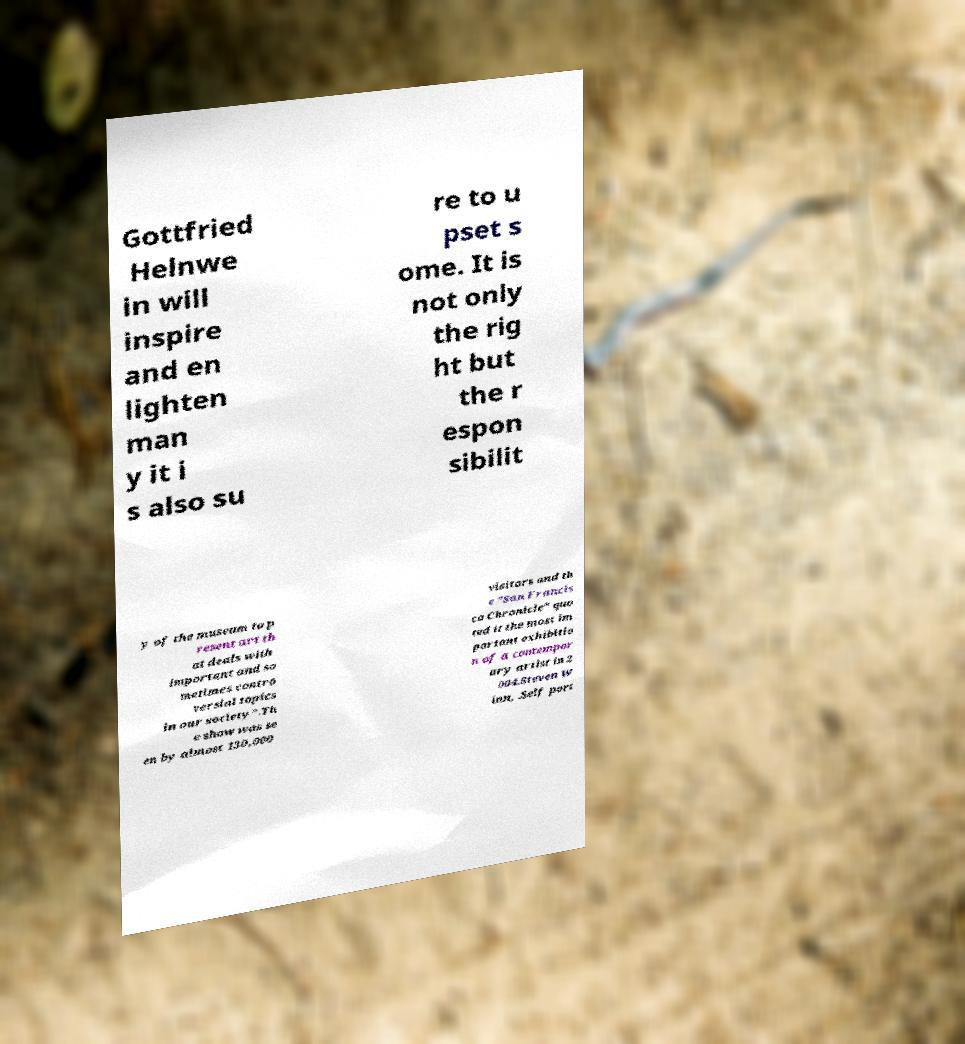Could you extract and type out the text from this image? Gottfried Helnwe in will inspire and en lighten man y it i s also su re to u pset s ome. It is not only the rig ht but the r espon sibilit y of the museum to p resent art th at deals with important and so metimes contro versial topics in our society".Th e show was se en by almost 130,000 visitors and th e "San Francis co Chronicle" quo ted it the most im portant exhibitio n of a contempor ary artist in 2 004.Steven W inn, .Self port 